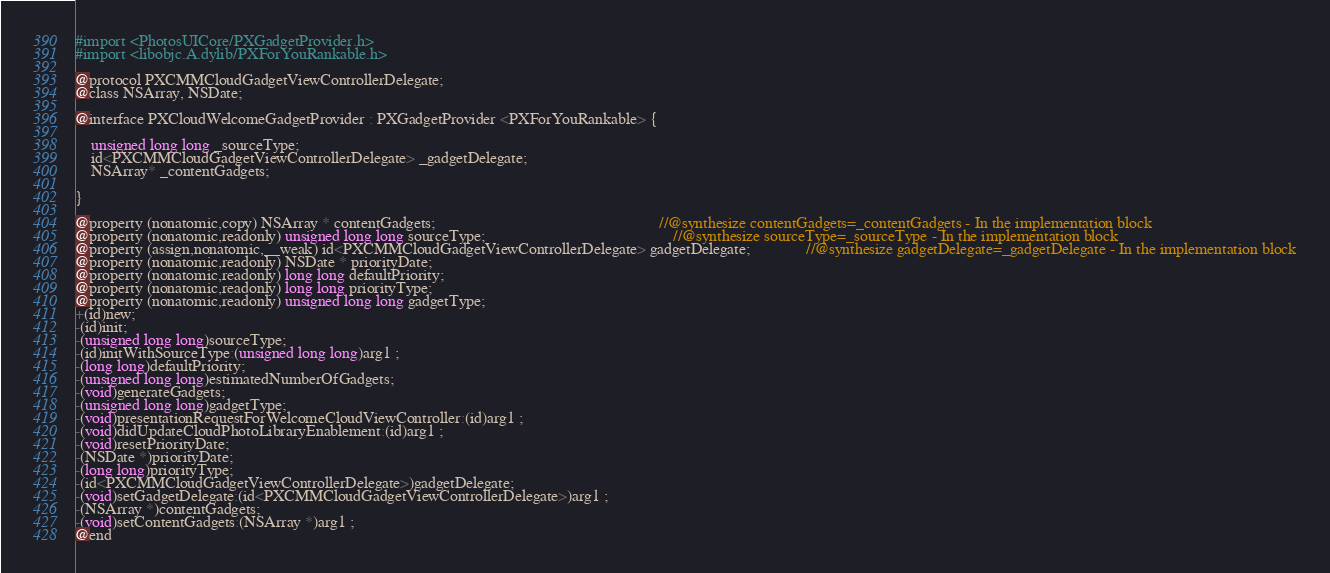<code> <loc_0><loc_0><loc_500><loc_500><_C_>
#import <PhotosUICore/PXGadgetProvider.h>
#import <libobjc.A.dylib/PXForYouRankable.h>

@protocol PXCMMCloudGadgetViewControllerDelegate;
@class NSArray, NSDate;

@interface PXCloudWelcomeGadgetProvider : PXGadgetProvider <PXForYouRankable> {

	unsigned long long _sourceType;
	id<PXCMMCloudGadgetViewControllerDelegate> _gadgetDelegate;
	NSArray* _contentGadgets;

}

@property (nonatomic,copy) NSArray * contentGadgets;                                                        //@synthesize contentGadgets=_contentGadgets - In the implementation block
@property (nonatomic,readonly) unsigned long long sourceType;                                               //@synthesize sourceType=_sourceType - In the implementation block
@property (assign,nonatomic,__weak) id<PXCMMCloudGadgetViewControllerDelegate> gadgetDelegate;              //@synthesize gadgetDelegate=_gadgetDelegate - In the implementation block
@property (nonatomic,readonly) NSDate * priorityDate; 
@property (nonatomic,readonly) long long defaultPriority; 
@property (nonatomic,readonly) long long priorityType; 
@property (nonatomic,readonly) unsigned long long gadgetType; 
+(id)new;
-(id)init;
-(unsigned long long)sourceType;
-(id)initWithSourceType:(unsigned long long)arg1 ;
-(long long)defaultPriority;
-(unsigned long long)estimatedNumberOfGadgets;
-(void)generateGadgets;
-(unsigned long long)gadgetType;
-(void)presentationRequestForWelcomeCloudViewController:(id)arg1 ;
-(void)didUpdateCloudPhotoLibraryEnablement:(id)arg1 ;
-(void)resetPriorityDate;
-(NSDate *)priorityDate;
-(long long)priorityType;
-(id<PXCMMCloudGadgetViewControllerDelegate>)gadgetDelegate;
-(void)setGadgetDelegate:(id<PXCMMCloudGadgetViewControllerDelegate>)arg1 ;
-(NSArray *)contentGadgets;
-(void)setContentGadgets:(NSArray *)arg1 ;
@end

</code> 